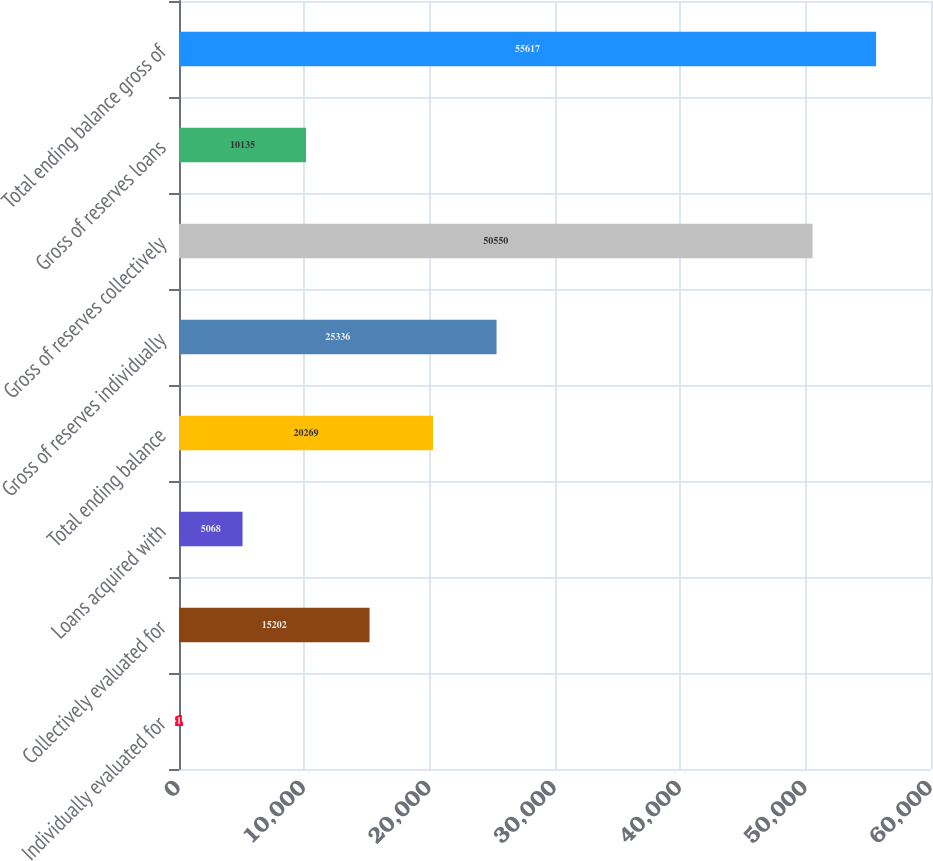Convert chart. <chart><loc_0><loc_0><loc_500><loc_500><bar_chart><fcel>Individually evaluated for<fcel>Collectively evaluated for<fcel>Loans acquired with<fcel>Total ending balance<fcel>Gross of reserves individually<fcel>Gross of reserves collectively<fcel>Gross of reserves loans<fcel>Total ending balance gross of<nl><fcel>1<fcel>15202<fcel>5068<fcel>20269<fcel>25336<fcel>50550<fcel>10135<fcel>55617<nl></chart> 